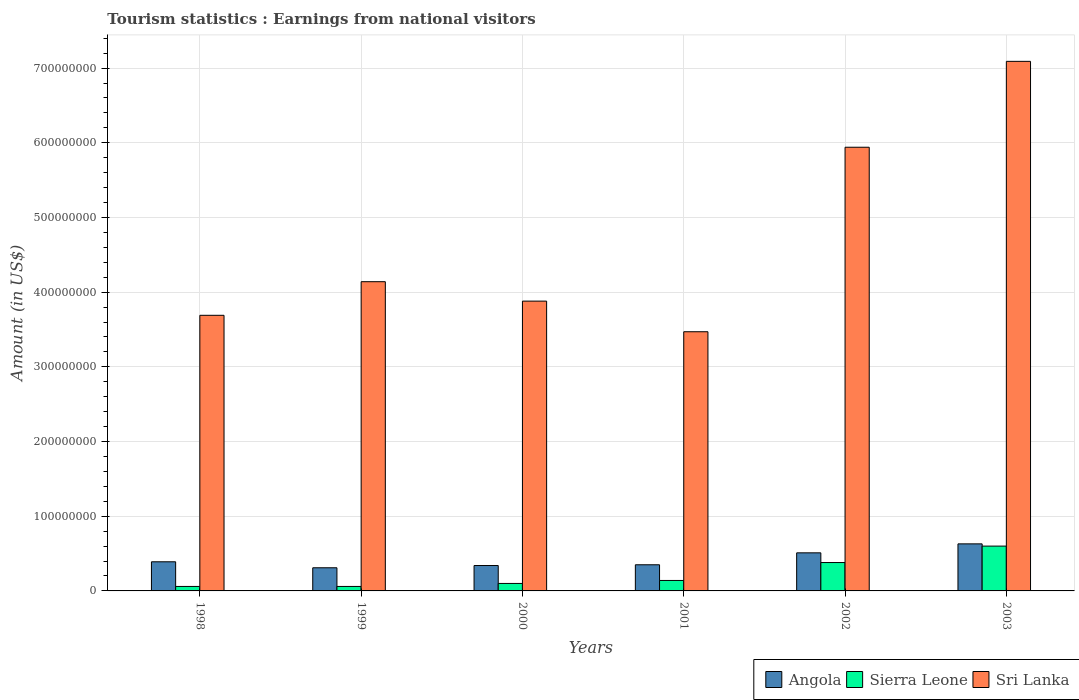How many different coloured bars are there?
Your answer should be compact. 3. How many bars are there on the 6th tick from the left?
Your response must be concise. 3. How many bars are there on the 1st tick from the right?
Provide a succinct answer. 3. What is the label of the 3rd group of bars from the left?
Provide a succinct answer. 2000. What is the earnings from national visitors in Angola in 1998?
Make the answer very short. 3.90e+07. Across all years, what is the maximum earnings from national visitors in Sri Lanka?
Make the answer very short. 7.09e+08. Across all years, what is the minimum earnings from national visitors in Sierra Leone?
Make the answer very short. 6.00e+06. What is the total earnings from national visitors in Sierra Leone in the graph?
Your response must be concise. 1.34e+08. What is the difference between the earnings from national visitors in Sri Lanka in 1998 and that in 2001?
Ensure brevity in your answer.  2.20e+07. What is the difference between the earnings from national visitors in Sri Lanka in 2000 and the earnings from national visitors in Sierra Leone in 1998?
Ensure brevity in your answer.  3.82e+08. What is the average earnings from national visitors in Angola per year?
Your answer should be very brief. 4.22e+07. In the year 2000, what is the difference between the earnings from national visitors in Angola and earnings from national visitors in Sri Lanka?
Your answer should be very brief. -3.54e+08. In how many years, is the earnings from national visitors in Sierra Leone greater than 700000000 US$?
Ensure brevity in your answer.  0. What is the difference between the highest and the lowest earnings from national visitors in Sri Lanka?
Offer a very short reply. 3.62e+08. In how many years, is the earnings from national visitors in Sri Lanka greater than the average earnings from national visitors in Sri Lanka taken over all years?
Your response must be concise. 2. Is the sum of the earnings from national visitors in Sri Lanka in 1998 and 2003 greater than the maximum earnings from national visitors in Sierra Leone across all years?
Ensure brevity in your answer.  Yes. What does the 3rd bar from the left in 2000 represents?
Offer a very short reply. Sri Lanka. What does the 2nd bar from the right in 2002 represents?
Provide a succinct answer. Sierra Leone. How many bars are there?
Offer a terse response. 18. How many years are there in the graph?
Ensure brevity in your answer.  6. Does the graph contain any zero values?
Your response must be concise. No. Does the graph contain grids?
Your answer should be compact. Yes. How many legend labels are there?
Your answer should be very brief. 3. What is the title of the graph?
Make the answer very short. Tourism statistics : Earnings from national visitors. What is the Amount (in US$) of Angola in 1998?
Provide a succinct answer. 3.90e+07. What is the Amount (in US$) of Sierra Leone in 1998?
Provide a short and direct response. 6.00e+06. What is the Amount (in US$) of Sri Lanka in 1998?
Give a very brief answer. 3.69e+08. What is the Amount (in US$) in Angola in 1999?
Your answer should be compact. 3.10e+07. What is the Amount (in US$) of Sri Lanka in 1999?
Keep it short and to the point. 4.14e+08. What is the Amount (in US$) in Angola in 2000?
Your answer should be compact. 3.40e+07. What is the Amount (in US$) in Sri Lanka in 2000?
Your response must be concise. 3.88e+08. What is the Amount (in US$) of Angola in 2001?
Your answer should be very brief. 3.50e+07. What is the Amount (in US$) in Sierra Leone in 2001?
Offer a terse response. 1.40e+07. What is the Amount (in US$) in Sri Lanka in 2001?
Offer a very short reply. 3.47e+08. What is the Amount (in US$) of Angola in 2002?
Make the answer very short. 5.10e+07. What is the Amount (in US$) in Sierra Leone in 2002?
Keep it short and to the point. 3.80e+07. What is the Amount (in US$) in Sri Lanka in 2002?
Provide a short and direct response. 5.94e+08. What is the Amount (in US$) in Angola in 2003?
Your answer should be very brief. 6.30e+07. What is the Amount (in US$) of Sierra Leone in 2003?
Ensure brevity in your answer.  6.00e+07. What is the Amount (in US$) in Sri Lanka in 2003?
Keep it short and to the point. 7.09e+08. Across all years, what is the maximum Amount (in US$) in Angola?
Provide a succinct answer. 6.30e+07. Across all years, what is the maximum Amount (in US$) in Sierra Leone?
Provide a succinct answer. 6.00e+07. Across all years, what is the maximum Amount (in US$) in Sri Lanka?
Your answer should be compact. 7.09e+08. Across all years, what is the minimum Amount (in US$) of Angola?
Your answer should be compact. 3.10e+07. Across all years, what is the minimum Amount (in US$) in Sierra Leone?
Make the answer very short. 6.00e+06. Across all years, what is the minimum Amount (in US$) of Sri Lanka?
Your answer should be very brief. 3.47e+08. What is the total Amount (in US$) in Angola in the graph?
Your answer should be very brief. 2.53e+08. What is the total Amount (in US$) in Sierra Leone in the graph?
Give a very brief answer. 1.34e+08. What is the total Amount (in US$) of Sri Lanka in the graph?
Provide a short and direct response. 2.82e+09. What is the difference between the Amount (in US$) in Angola in 1998 and that in 1999?
Give a very brief answer. 8.00e+06. What is the difference between the Amount (in US$) of Sri Lanka in 1998 and that in 1999?
Provide a succinct answer. -4.50e+07. What is the difference between the Amount (in US$) of Sierra Leone in 1998 and that in 2000?
Provide a succinct answer. -4.00e+06. What is the difference between the Amount (in US$) of Sri Lanka in 1998 and that in 2000?
Your answer should be compact. -1.90e+07. What is the difference between the Amount (in US$) of Angola in 1998 and that in 2001?
Keep it short and to the point. 4.00e+06. What is the difference between the Amount (in US$) in Sierra Leone in 1998 and that in 2001?
Make the answer very short. -8.00e+06. What is the difference between the Amount (in US$) in Sri Lanka in 1998 and that in 2001?
Make the answer very short. 2.20e+07. What is the difference between the Amount (in US$) in Angola in 1998 and that in 2002?
Offer a terse response. -1.20e+07. What is the difference between the Amount (in US$) of Sierra Leone in 1998 and that in 2002?
Provide a short and direct response. -3.20e+07. What is the difference between the Amount (in US$) in Sri Lanka in 1998 and that in 2002?
Your answer should be very brief. -2.25e+08. What is the difference between the Amount (in US$) of Angola in 1998 and that in 2003?
Ensure brevity in your answer.  -2.40e+07. What is the difference between the Amount (in US$) in Sierra Leone in 1998 and that in 2003?
Make the answer very short. -5.40e+07. What is the difference between the Amount (in US$) in Sri Lanka in 1998 and that in 2003?
Your answer should be very brief. -3.40e+08. What is the difference between the Amount (in US$) in Sierra Leone in 1999 and that in 2000?
Ensure brevity in your answer.  -4.00e+06. What is the difference between the Amount (in US$) in Sri Lanka in 1999 and that in 2000?
Give a very brief answer. 2.60e+07. What is the difference between the Amount (in US$) in Sierra Leone in 1999 and that in 2001?
Provide a succinct answer. -8.00e+06. What is the difference between the Amount (in US$) in Sri Lanka in 1999 and that in 2001?
Make the answer very short. 6.70e+07. What is the difference between the Amount (in US$) of Angola in 1999 and that in 2002?
Offer a very short reply. -2.00e+07. What is the difference between the Amount (in US$) in Sierra Leone in 1999 and that in 2002?
Ensure brevity in your answer.  -3.20e+07. What is the difference between the Amount (in US$) in Sri Lanka in 1999 and that in 2002?
Offer a terse response. -1.80e+08. What is the difference between the Amount (in US$) in Angola in 1999 and that in 2003?
Provide a short and direct response. -3.20e+07. What is the difference between the Amount (in US$) of Sierra Leone in 1999 and that in 2003?
Make the answer very short. -5.40e+07. What is the difference between the Amount (in US$) in Sri Lanka in 1999 and that in 2003?
Provide a short and direct response. -2.95e+08. What is the difference between the Amount (in US$) in Angola in 2000 and that in 2001?
Offer a terse response. -1.00e+06. What is the difference between the Amount (in US$) of Sierra Leone in 2000 and that in 2001?
Your response must be concise. -4.00e+06. What is the difference between the Amount (in US$) of Sri Lanka in 2000 and that in 2001?
Your answer should be very brief. 4.10e+07. What is the difference between the Amount (in US$) in Angola in 2000 and that in 2002?
Provide a succinct answer. -1.70e+07. What is the difference between the Amount (in US$) in Sierra Leone in 2000 and that in 2002?
Make the answer very short. -2.80e+07. What is the difference between the Amount (in US$) of Sri Lanka in 2000 and that in 2002?
Ensure brevity in your answer.  -2.06e+08. What is the difference between the Amount (in US$) of Angola in 2000 and that in 2003?
Make the answer very short. -2.90e+07. What is the difference between the Amount (in US$) of Sierra Leone in 2000 and that in 2003?
Make the answer very short. -5.00e+07. What is the difference between the Amount (in US$) of Sri Lanka in 2000 and that in 2003?
Your answer should be very brief. -3.21e+08. What is the difference between the Amount (in US$) in Angola in 2001 and that in 2002?
Keep it short and to the point. -1.60e+07. What is the difference between the Amount (in US$) of Sierra Leone in 2001 and that in 2002?
Offer a very short reply. -2.40e+07. What is the difference between the Amount (in US$) in Sri Lanka in 2001 and that in 2002?
Provide a short and direct response. -2.47e+08. What is the difference between the Amount (in US$) in Angola in 2001 and that in 2003?
Offer a very short reply. -2.80e+07. What is the difference between the Amount (in US$) of Sierra Leone in 2001 and that in 2003?
Offer a terse response. -4.60e+07. What is the difference between the Amount (in US$) in Sri Lanka in 2001 and that in 2003?
Provide a short and direct response. -3.62e+08. What is the difference between the Amount (in US$) of Angola in 2002 and that in 2003?
Make the answer very short. -1.20e+07. What is the difference between the Amount (in US$) of Sierra Leone in 2002 and that in 2003?
Your answer should be very brief. -2.20e+07. What is the difference between the Amount (in US$) in Sri Lanka in 2002 and that in 2003?
Provide a short and direct response. -1.15e+08. What is the difference between the Amount (in US$) in Angola in 1998 and the Amount (in US$) in Sierra Leone in 1999?
Make the answer very short. 3.30e+07. What is the difference between the Amount (in US$) of Angola in 1998 and the Amount (in US$) of Sri Lanka in 1999?
Provide a succinct answer. -3.75e+08. What is the difference between the Amount (in US$) in Sierra Leone in 1998 and the Amount (in US$) in Sri Lanka in 1999?
Make the answer very short. -4.08e+08. What is the difference between the Amount (in US$) of Angola in 1998 and the Amount (in US$) of Sierra Leone in 2000?
Keep it short and to the point. 2.90e+07. What is the difference between the Amount (in US$) of Angola in 1998 and the Amount (in US$) of Sri Lanka in 2000?
Your answer should be very brief. -3.49e+08. What is the difference between the Amount (in US$) in Sierra Leone in 1998 and the Amount (in US$) in Sri Lanka in 2000?
Your answer should be very brief. -3.82e+08. What is the difference between the Amount (in US$) in Angola in 1998 and the Amount (in US$) in Sierra Leone in 2001?
Your response must be concise. 2.50e+07. What is the difference between the Amount (in US$) in Angola in 1998 and the Amount (in US$) in Sri Lanka in 2001?
Your answer should be very brief. -3.08e+08. What is the difference between the Amount (in US$) in Sierra Leone in 1998 and the Amount (in US$) in Sri Lanka in 2001?
Your response must be concise. -3.41e+08. What is the difference between the Amount (in US$) of Angola in 1998 and the Amount (in US$) of Sierra Leone in 2002?
Keep it short and to the point. 1.00e+06. What is the difference between the Amount (in US$) of Angola in 1998 and the Amount (in US$) of Sri Lanka in 2002?
Your answer should be compact. -5.55e+08. What is the difference between the Amount (in US$) in Sierra Leone in 1998 and the Amount (in US$) in Sri Lanka in 2002?
Offer a very short reply. -5.88e+08. What is the difference between the Amount (in US$) in Angola in 1998 and the Amount (in US$) in Sierra Leone in 2003?
Ensure brevity in your answer.  -2.10e+07. What is the difference between the Amount (in US$) of Angola in 1998 and the Amount (in US$) of Sri Lanka in 2003?
Your response must be concise. -6.70e+08. What is the difference between the Amount (in US$) in Sierra Leone in 1998 and the Amount (in US$) in Sri Lanka in 2003?
Provide a short and direct response. -7.03e+08. What is the difference between the Amount (in US$) of Angola in 1999 and the Amount (in US$) of Sierra Leone in 2000?
Make the answer very short. 2.10e+07. What is the difference between the Amount (in US$) in Angola in 1999 and the Amount (in US$) in Sri Lanka in 2000?
Provide a short and direct response. -3.57e+08. What is the difference between the Amount (in US$) of Sierra Leone in 1999 and the Amount (in US$) of Sri Lanka in 2000?
Keep it short and to the point. -3.82e+08. What is the difference between the Amount (in US$) of Angola in 1999 and the Amount (in US$) of Sierra Leone in 2001?
Ensure brevity in your answer.  1.70e+07. What is the difference between the Amount (in US$) in Angola in 1999 and the Amount (in US$) in Sri Lanka in 2001?
Offer a very short reply. -3.16e+08. What is the difference between the Amount (in US$) in Sierra Leone in 1999 and the Amount (in US$) in Sri Lanka in 2001?
Your answer should be compact. -3.41e+08. What is the difference between the Amount (in US$) in Angola in 1999 and the Amount (in US$) in Sierra Leone in 2002?
Offer a terse response. -7.00e+06. What is the difference between the Amount (in US$) in Angola in 1999 and the Amount (in US$) in Sri Lanka in 2002?
Provide a short and direct response. -5.63e+08. What is the difference between the Amount (in US$) of Sierra Leone in 1999 and the Amount (in US$) of Sri Lanka in 2002?
Your response must be concise. -5.88e+08. What is the difference between the Amount (in US$) in Angola in 1999 and the Amount (in US$) in Sierra Leone in 2003?
Give a very brief answer. -2.90e+07. What is the difference between the Amount (in US$) in Angola in 1999 and the Amount (in US$) in Sri Lanka in 2003?
Your response must be concise. -6.78e+08. What is the difference between the Amount (in US$) in Sierra Leone in 1999 and the Amount (in US$) in Sri Lanka in 2003?
Provide a short and direct response. -7.03e+08. What is the difference between the Amount (in US$) of Angola in 2000 and the Amount (in US$) of Sri Lanka in 2001?
Offer a very short reply. -3.13e+08. What is the difference between the Amount (in US$) in Sierra Leone in 2000 and the Amount (in US$) in Sri Lanka in 2001?
Your response must be concise. -3.37e+08. What is the difference between the Amount (in US$) of Angola in 2000 and the Amount (in US$) of Sierra Leone in 2002?
Keep it short and to the point. -4.00e+06. What is the difference between the Amount (in US$) in Angola in 2000 and the Amount (in US$) in Sri Lanka in 2002?
Ensure brevity in your answer.  -5.60e+08. What is the difference between the Amount (in US$) of Sierra Leone in 2000 and the Amount (in US$) of Sri Lanka in 2002?
Provide a short and direct response. -5.84e+08. What is the difference between the Amount (in US$) of Angola in 2000 and the Amount (in US$) of Sierra Leone in 2003?
Your answer should be very brief. -2.60e+07. What is the difference between the Amount (in US$) in Angola in 2000 and the Amount (in US$) in Sri Lanka in 2003?
Provide a succinct answer. -6.75e+08. What is the difference between the Amount (in US$) of Sierra Leone in 2000 and the Amount (in US$) of Sri Lanka in 2003?
Offer a terse response. -6.99e+08. What is the difference between the Amount (in US$) of Angola in 2001 and the Amount (in US$) of Sri Lanka in 2002?
Your answer should be compact. -5.59e+08. What is the difference between the Amount (in US$) in Sierra Leone in 2001 and the Amount (in US$) in Sri Lanka in 2002?
Your answer should be compact. -5.80e+08. What is the difference between the Amount (in US$) of Angola in 2001 and the Amount (in US$) of Sierra Leone in 2003?
Give a very brief answer. -2.50e+07. What is the difference between the Amount (in US$) in Angola in 2001 and the Amount (in US$) in Sri Lanka in 2003?
Offer a very short reply. -6.74e+08. What is the difference between the Amount (in US$) in Sierra Leone in 2001 and the Amount (in US$) in Sri Lanka in 2003?
Your response must be concise. -6.95e+08. What is the difference between the Amount (in US$) in Angola in 2002 and the Amount (in US$) in Sierra Leone in 2003?
Your answer should be very brief. -9.00e+06. What is the difference between the Amount (in US$) of Angola in 2002 and the Amount (in US$) of Sri Lanka in 2003?
Ensure brevity in your answer.  -6.58e+08. What is the difference between the Amount (in US$) in Sierra Leone in 2002 and the Amount (in US$) in Sri Lanka in 2003?
Offer a terse response. -6.71e+08. What is the average Amount (in US$) of Angola per year?
Provide a short and direct response. 4.22e+07. What is the average Amount (in US$) of Sierra Leone per year?
Give a very brief answer. 2.23e+07. What is the average Amount (in US$) of Sri Lanka per year?
Give a very brief answer. 4.70e+08. In the year 1998, what is the difference between the Amount (in US$) in Angola and Amount (in US$) in Sierra Leone?
Ensure brevity in your answer.  3.30e+07. In the year 1998, what is the difference between the Amount (in US$) in Angola and Amount (in US$) in Sri Lanka?
Provide a short and direct response. -3.30e+08. In the year 1998, what is the difference between the Amount (in US$) in Sierra Leone and Amount (in US$) in Sri Lanka?
Provide a succinct answer. -3.63e+08. In the year 1999, what is the difference between the Amount (in US$) in Angola and Amount (in US$) in Sierra Leone?
Provide a short and direct response. 2.50e+07. In the year 1999, what is the difference between the Amount (in US$) of Angola and Amount (in US$) of Sri Lanka?
Make the answer very short. -3.83e+08. In the year 1999, what is the difference between the Amount (in US$) in Sierra Leone and Amount (in US$) in Sri Lanka?
Ensure brevity in your answer.  -4.08e+08. In the year 2000, what is the difference between the Amount (in US$) in Angola and Amount (in US$) in Sierra Leone?
Your answer should be compact. 2.40e+07. In the year 2000, what is the difference between the Amount (in US$) in Angola and Amount (in US$) in Sri Lanka?
Your answer should be very brief. -3.54e+08. In the year 2000, what is the difference between the Amount (in US$) in Sierra Leone and Amount (in US$) in Sri Lanka?
Offer a terse response. -3.78e+08. In the year 2001, what is the difference between the Amount (in US$) of Angola and Amount (in US$) of Sierra Leone?
Offer a very short reply. 2.10e+07. In the year 2001, what is the difference between the Amount (in US$) of Angola and Amount (in US$) of Sri Lanka?
Provide a succinct answer. -3.12e+08. In the year 2001, what is the difference between the Amount (in US$) of Sierra Leone and Amount (in US$) of Sri Lanka?
Make the answer very short. -3.33e+08. In the year 2002, what is the difference between the Amount (in US$) of Angola and Amount (in US$) of Sierra Leone?
Keep it short and to the point. 1.30e+07. In the year 2002, what is the difference between the Amount (in US$) of Angola and Amount (in US$) of Sri Lanka?
Give a very brief answer. -5.43e+08. In the year 2002, what is the difference between the Amount (in US$) in Sierra Leone and Amount (in US$) in Sri Lanka?
Offer a very short reply. -5.56e+08. In the year 2003, what is the difference between the Amount (in US$) in Angola and Amount (in US$) in Sierra Leone?
Your answer should be very brief. 3.00e+06. In the year 2003, what is the difference between the Amount (in US$) of Angola and Amount (in US$) of Sri Lanka?
Your answer should be very brief. -6.46e+08. In the year 2003, what is the difference between the Amount (in US$) of Sierra Leone and Amount (in US$) of Sri Lanka?
Provide a succinct answer. -6.49e+08. What is the ratio of the Amount (in US$) in Angola in 1998 to that in 1999?
Your answer should be very brief. 1.26. What is the ratio of the Amount (in US$) of Sri Lanka in 1998 to that in 1999?
Your response must be concise. 0.89. What is the ratio of the Amount (in US$) in Angola in 1998 to that in 2000?
Provide a succinct answer. 1.15. What is the ratio of the Amount (in US$) of Sri Lanka in 1998 to that in 2000?
Provide a short and direct response. 0.95. What is the ratio of the Amount (in US$) in Angola in 1998 to that in 2001?
Keep it short and to the point. 1.11. What is the ratio of the Amount (in US$) of Sierra Leone in 1998 to that in 2001?
Ensure brevity in your answer.  0.43. What is the ratio of the Amount (in US$) in Sri Lanka in 1998 to that in 2001?
Make the answer very short. 1.06. What is the ratio of the Amount (in US$) in Angola in 1998 to that in 2002?
Give a very brief answer. 0.76. What is the ratio of the Amount (in US$) of Sierra Leone in 1998 to that in 2002?
Your answer should be compact. 0.16. What is the ratio of the Amount (in US$) of Sri Lanka in 1998 to that in 2002?
Keep it short and to the point. 0.62. What is the ratio of the Amount (in US$) in Angola in 1998 to that in 2003?
Your answer should be very brief. 0.62. What is the ratio of the Amount (in US$) of Sri Lanka in 1998 to that in 2003?
Provide a short and direct response. 0.52. What is the ratio of the Amount (in US$) of Angola in 1999 to that in 2000?
Provide a short and direct response. 0.91. What is the ratio of the Amount (in US$) of Sierra Leone in 1999 to that in 2000?
Make the answer very short. 0.6. What is the ratio of the Amount (in US$) in Sri Lanka in 1999 to that in 2000?
Provide a succinct answer. 1.07. What is the ratio of the Amount (in US$) of Angola in 1999 to that in 2001?
Make the answer very short. 0.89. What is the ratio of the Amount (in US$) of Sierra Leone in 1999 to that in 2001?
Provide a short and direct response. 0.43. What is the ratio of the Amount (in US$) of Sri Lanka in 1999 to that in 2001?
Ensure brevity in your answer.  1.19. What is the ratio of the Amount (in US$) of Angola in 1999 to that in 2002?
Your answer should be very brief. 0.61. What is the ratio of the Amount (in US$) in Sierra Leone in 1999 to that in 2002?
Keep it short and to the point. 0.16. What is the ratio of the Amount (in US$) of Sri Lanka in 1999 to that in 2002?
Your answer should be very brief. 0.7. What is the ratio of the Amount (in US$) in Angola in 1999 to that in 2003?
Ensure brevity in your answer.  0.49. What is the ratio of the Amount (in US$) in Sierra Leone in 1999 to that in 2003?
Your answer should be compact. 0.1. What is the ratio of the Amount (in US$) in Sri Lanka in 1999 to that in 2003?
Your response must be concise. 0.58. What is the ratio of the Amount (in US$) of Angola in 2000 to that in 2001?
Offer a terse response. 0.97. What is the ratio of the Amount (in US$) of Sri Lanka in 2000 to that in 2001?
Your answer should be very brief. 1.12. What is the ratio of the Amount (in US$) in Sierra Leone in 2000 to that in 2002?
Ensure brevity in your answer.  0.26. What is the ratio of the Amount (in US$) of Sri Lanka in 2000 to that in 2002?
Offer a very short reply. 0.65. What is the ratio of the Amount (in US$) in Angola in 2000 to that in 2003?
Make the answer very short. 0.54. What is the ratio of the Amount (in US$) in Sri Lanka in 2000 to that in 2003?
Ensure brevity in your answer.  0.55. What is the ratio of the Amount (in US$) of Angola in 2001 to that in 2002?
Offer a terse response. 0.69. What is the ratio of the Amount (in US$) in Sierra Leone in 2001 to that in 2002?
Offer a terse response. 0.37. What is the ratio of the Amount (in US$) in Sri Lanka in 2001 to that in 2002?
Make the answer very short. 0.58. What is the ratio of the Amount (in US$) of Angola in 2001 to that in 2003?
Your response must be concise. 0.56. What is the ratio of the Amount (in US$) in Sierra Leone in 2001 to that in 2003?
Give a very brief answer. 0.23. What is the ratio of the Amount (in US$) of Sri Lanka in 2001 to that in 2003?
Offer a very short reply. 0.49. What is the ratio of the Amount (in US$) in Angola in 2002 to that in 2003?
Give a very brief answer. 0.81. What is the ratio of the Amount (in US$) of Sierra Leone in 2002 to that in 2003?
Offer a terse response. 0.63. What is the ratio of the Amount (in US$) in Sri Lanka in 2002 to that in 2003?
Your answer should be very brief. 0.84. What is the difference between the highest and the second highest Amount (in US$) in Angola?
Ensure brevity in your answer.  1.20e+07. What is the difference between the highest and the second highest Amount (in US$) in Sierra Leone?
Make the answer very short. 2.20e+07. What is the difference between the highest and the second highest Amount (in US$) in Sri Lanka?
Make the answer very short. 1.15e+08. What is the difference between the highest and the lowest Amount (in US$) in Angola?
Your answer should be compact. 3.20e+07. What is the difference between the highest and the lowest Amount (in US$) of Sierra Leone?
Offer a terse response. 5.40e+07. What is the difference between the highest and the lowest Amount (in US$) of Sri Lanka?
Your answer should be compact. 3.62e+08. 